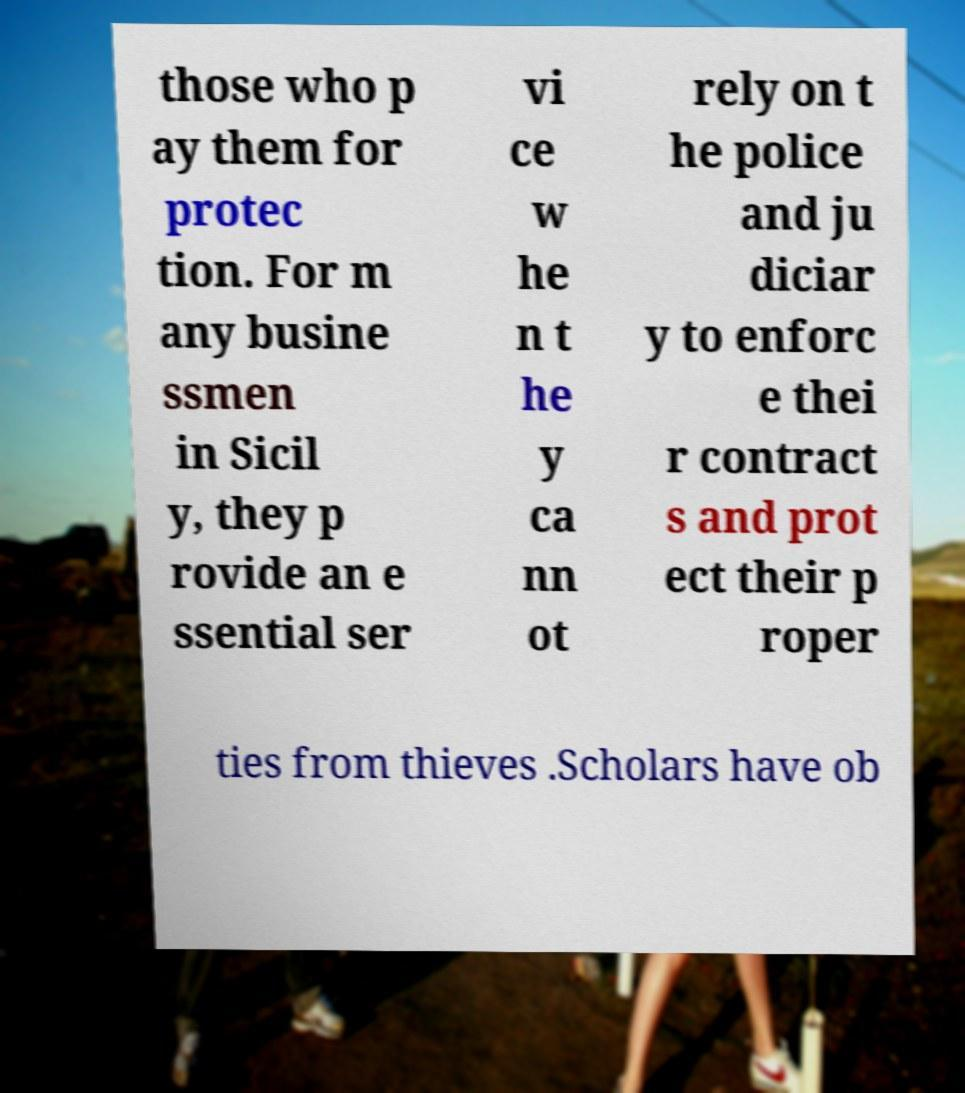Could you assist in decoding the text presented in this image and type it out clearly? those who p ay them for protec tion. For m any busine ssmen in Sicil y, they p rovide an e ssential ser vi ce w he n t he y ca nn ot rely on t he police and ju diciar y to enforc e thei r contract s and prot ect their p roper ties from thieves .Scholars have ob 